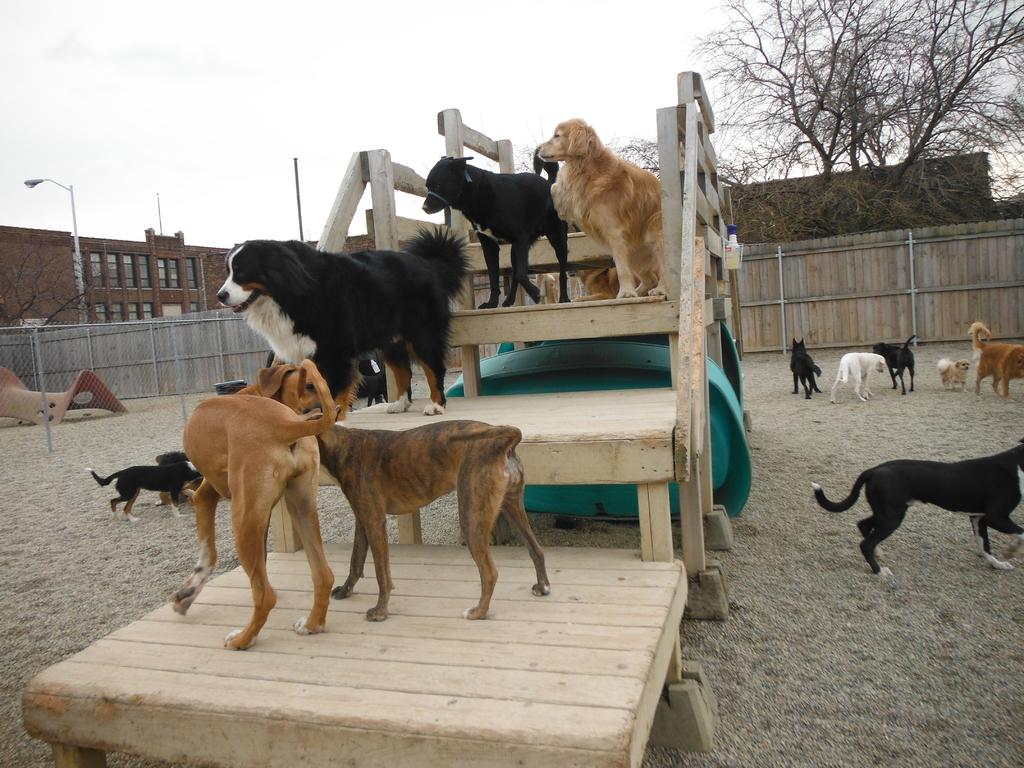What animals can be seen in the image are on the ground? There are dogs on the ground in the image. Where else can dogs be seen in the image? Dogs can also be seen on the stairs in the image. What type of structures can be seen in the background? Buildings are present in the background of the image. What natural elements can be seen in the background? Trees are present in the background of the image. What type of barrier can be seen in the background? There is a mesh in the background of the image. What type of man-made structures are visible in the background? Street lights and street poles are present in the background of the image. What part of the natural environment is visible in the background? The sky is visible in the background of the image. Where is the bear located in the image? There is no bear present in the image. What type of mailbox can be seen near the dogs in the image? There is no mailbox present in the image. 